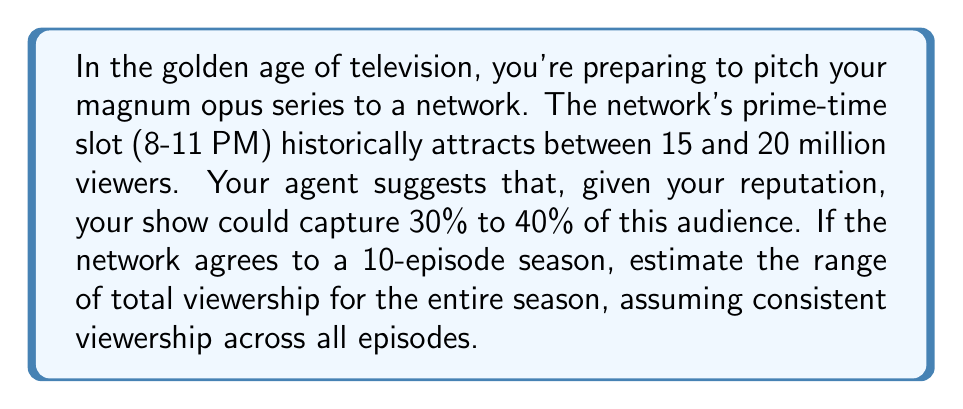Provide a solution to this math problem. Let's approach this step-by-step:

1) First, we need to establish the range of potential viewers per episode:

   Lower bound: $15 \text{ million} \times 30\% = 4.5 \text{ million}$
   Upper bound: $20 \text{ million} \times 40\% = 8 \text{ million}$

2) Now, we need to calculate the total viewership for a 10-episode season:

   Lower bound: $4.5 \text{ million} \times 10 \text{ episodes} = 45 \text{ million}$
   Upper bound: $8 \text{ million} \times 10 \text{ episodes} = 80 \text{ million}$

3) We can express this as an inequality:

   $$45 \text{ million} \leq \text{Total Viewership} \leq 80 \text{ million}$$

This inequality represents the estimated range of total viewership for the entire season.
Answer: $45 \text{ million} \leq \text{Total Viewership} \leq 80 \text{ million}$ 